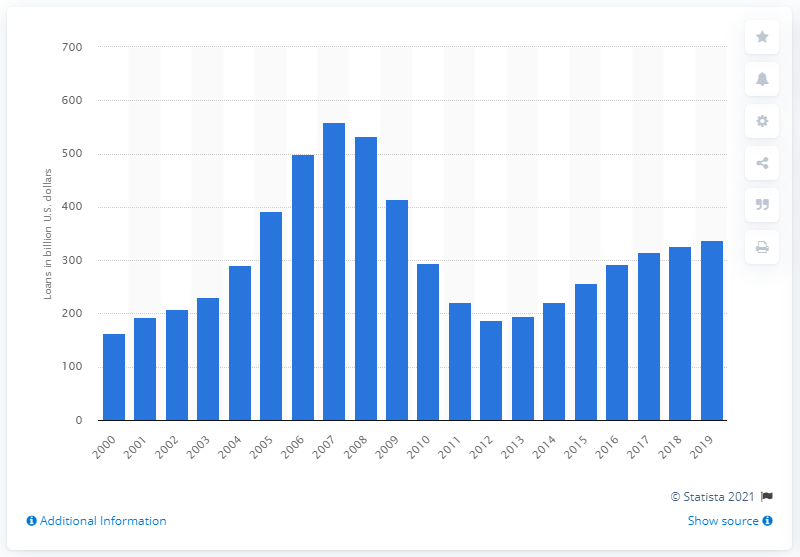Specify some key components in this picture. In 2019, the value of domestic office loans secured by real estate for construction and land development granted by FDIC-insured commercial banks was approximately $338.13 billion. 